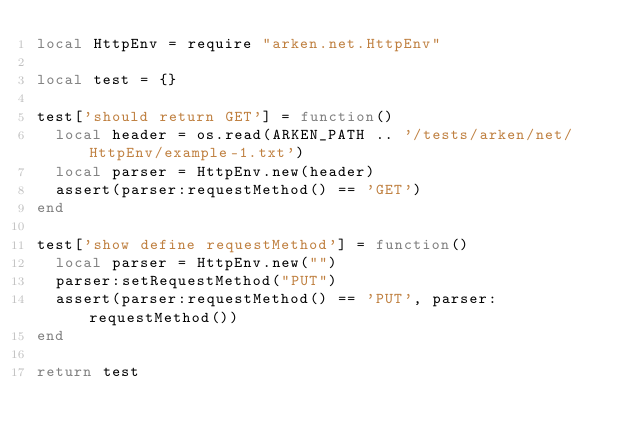<code> <loc_0><loc_0><loc_500><loc_500><_Lua_>local HttpEnv = require "arken.net.HttpEnv"

local test = {}

test['should return GET'] = function()
  local header = os.read(ARKEN_PATH .. '/tests/arken/net/HttpEnv/example-1.txt')
  local parser = HttpEnv.new(header)
  assert(parser:requestMethod() == 'GET')
end

test['show define requestMethod'] = function()
  local parser = HttpEnv.new("")
  parser:setRequestMethod("PUT")
  assert(parser:requestMethod() == 'PUT', parser:requestMethod())
end

return test
</code> 